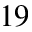<formula> <loc_0><loc_0><loc_500><loc_500>^ { 1 9 }</formula> 